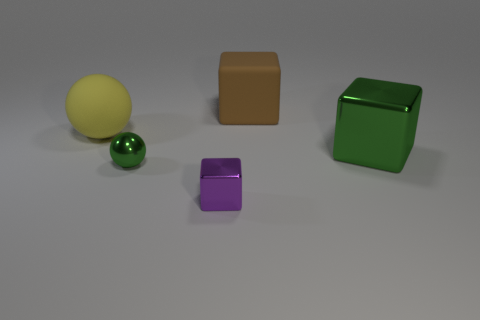Subtract all big cubes. How many cubes are left? 1 Add 4 gray cubes. How many objects exist? 9 Subtract all brown blocks. How many blocks are left? 2 Add 5 tiny purple blocks. How many tiny purple blocks are left? 6 Add 3 tiny blocks. How many tiny blocks exist? 4 Subtract 0 gray balls. How many objects are left? 5 Subtract all blocks. How many objects are left? 2 Subtract 1 blocks. How many blocks are left? 2 Subtract all brown spheres. Subtract all gray cubes. How many spheres are left? 2 Subtract all green blocks. How many gray spheres are left? 0 